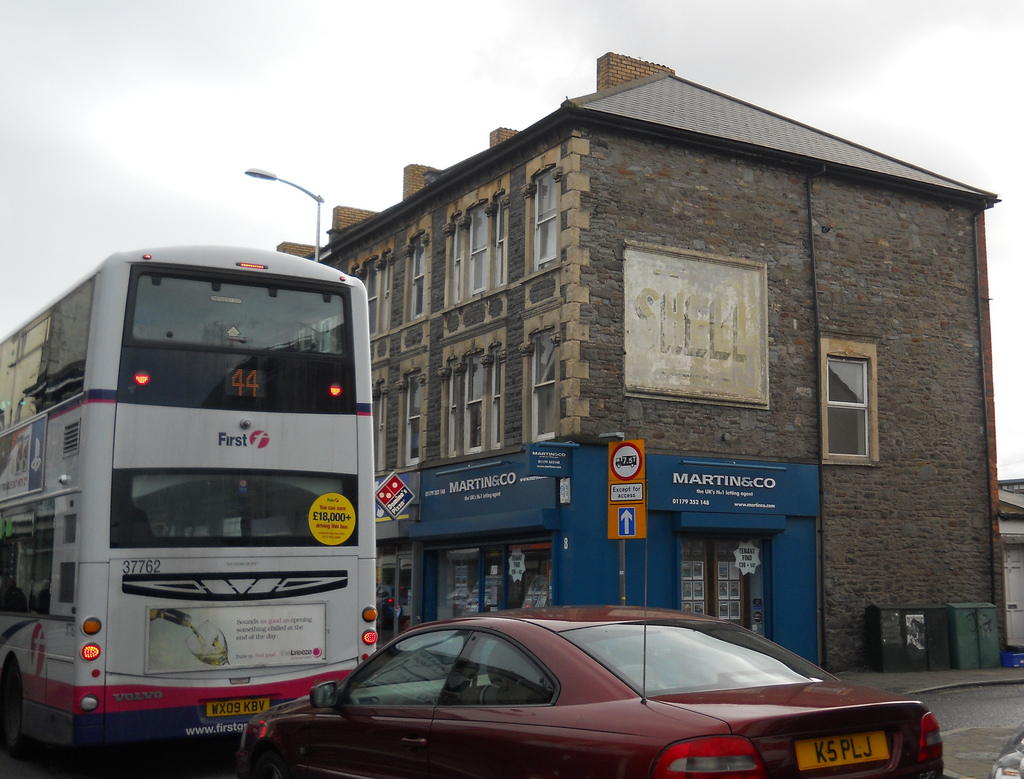Please provide the bounding box coordinate of the region this sentence describes: Handle of a maroon car. The bounding box coordinate for the handle of the maroon car is approximately [0.39, 0.83, 0.42, 0.85]. This highlights the specific area where the car's handle is located, ensuring a precise pointer. 